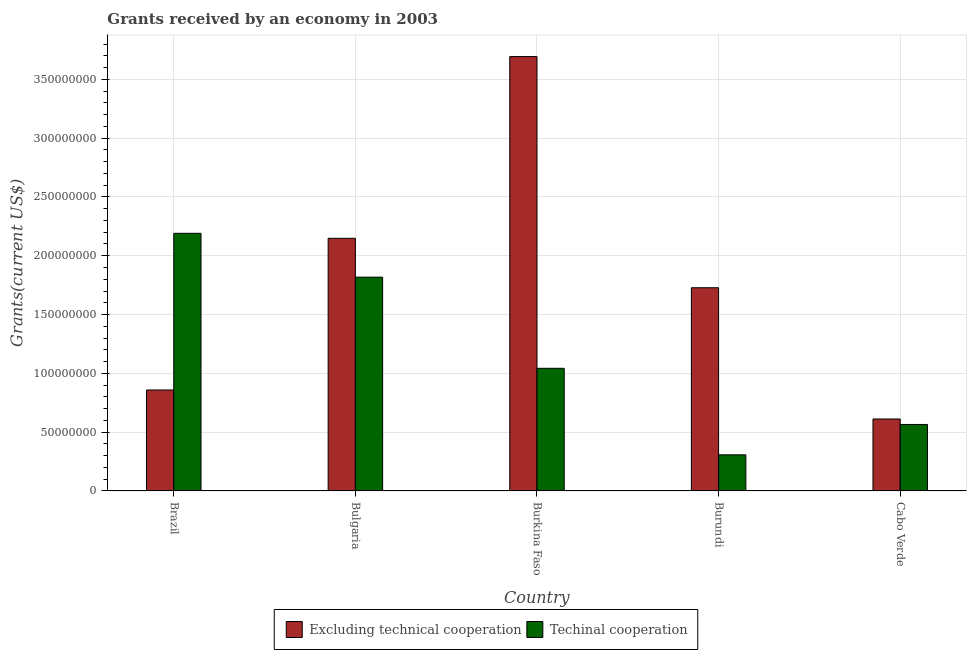How many groups of bars are there?
Your answer should be very brief. 5. What is the label of the 4th group of bars from the left?
Provide a succinct answer. Burundi. What is the amount of grants received(excluding technical cooperation) in Burundi?
Your answer should be compact. 1.73e+08. Across all countries, what is the maximum amount of grants received(including technical cooperation)?
Your answer should be very brief. 2.19e+08. Across all countries, what is the minimum amount of grants received(including technical cooperation)?
Offer a terse response. 3.07e+07. In which country was the amount of grants received(excluding technical cooperation) maximum?
Ensure brevity in your answer.  Burkina Faso. In which country was the amount of grants received(including technical cooperation) minimum?
Provide a short and direct response. Burundi. What is the total amount of grants received(excluding technical cooperation) in the graph?
Make the answer very short. 9.04e+08. What is the difference between the amount of grants received(excluding technical cooperation) in Burundi and that in Cabo Verde?
Keep it short and to the point. 1.12e+08. What is the difference between the amount of grants received(including technical cooperation) in Burundi and the amount of grants received(excluding technical cooperation) in Cabo Verde?
Make the answer very short. -3.05e+07. What is the average amount of grants received(excluding technical cooperation) per country?
Ensure brevity in your answer.  1.81e+08. What is the difference between the amount of grants received(including technical cooperation) and amount of grants received(excluding technical cooperation) in Burundi?
Provide a succinct answer. -1.42e+08. What is the ratio of the amount of grants received(including technical cooperation) in Brazil to that in Burundi?
Keep it short and to the point. 7.14. Is the amount of grants received(excluding technical cooperation) in Burundi less than that in Cabo Verde?
Offer a terse response. No. What is the difference between the highest and the second highest amount of grants received(excluding technical cooperation)?
Give a very brief answer. 1.55e+08. What is the difference between the highest and the lowest amount of grants received(including technical cooperation)?
Provide a succinct answer. 1.88e+08. In how many countries, is the amount of grants received(including technical cooperation) greater than the average amount of grants received(including technical cooperation) taken over all countries?
Give a very brief answer. 2. What does the 1st bar from the left in Cabo Verde represents?
Provide a succinct answer. Excluding technical cooperation. What does the 1st bar from the right in Bulgaria represents?
Your answer should be compact. Techinal cooperation. How many bars are there?
Keep it short and to the point. 10. Are all the bars in the graph horizontal?
Your answer should be very brief. No. How many countries are there in the graph?
Give a very brief answer. 5. Does the graph contain grids?
Offer a terse response. Yes. Where does the legend appear in the graph?
Give a very brief answer. Bottom center. How many legend labels are there?
Offer a terse response. 2. What is the title of the graph?
Give a very brief answer. Grants received by an economy in 2003. Does "current US$" appear as one of the legend labels in the graph?
Ensure brevity in your answer.  No. What is the label or title of the X-axis?
Offer a terse response. Country. What is the label or title of the Y-axis?
Provide a short and direct response. Grants(current US$). What is the Grants(current US$) in Excluding technical cooperation in Brazil?
Ensure brevity in your answer.  8.58e+07. What is the Grants(current US$) in Techinal cooperation in Brazil?
Give a very brief answer. 2.19e+08. What is the Grants(current US$) in Excluding technical cooperation in Bulgaria?
Give a very brief answer. 2.15e+08. What is the Grants(current US$) in Techinal cooperation in Bulgaria?
Your answer should be compact. 1.82e+08. What is the Grants(current US$) in Excluding technical cooperation in Burkina Faso?
Keep it short and to the point. 3.69e+08. What is the Grants(current US$) in Techinal cooperation in Burkina Faso?
Offer a terse response. 1.04e+08. What is the Grants(current US$) of Excluding technical cooperation in Burundi?
Your response must be concise. 1.73e+08. What is the Grants(current US$) in Techinal cooperation in Burundi?
Keep it short and to the point. 3.07e+07. What is the Grants(current US$) in Excluding technical cooperation in Cabo Verde?
Keep it short and to the point. 6.12e+07. What is the Grants(current US$) in Techinal cooperation in Cabo Verde?
Ensure brevity in your answer.  5.65e+07. Across all countries, what is the maximum Grants(current US$) of Excluding technical cooperation?
Provide a succinct answer. 3.69e+08. Across all countries, what is the maximum Grants(current US$) of Techinal cooperation?
Your answer should be compact. 2.19e+08. Across all countries, what is the minimum Grants(current US$) in Excluding technical cooperation?
Provide a short and direct response. 6.12e+07. Across all countries, what is the minimum Grants(current US$) in Techinal cooperation?
Make the answer very short. 3.07e+07. What is the total Grants(current US$) of Excluding technical cooperation in the graph?
Provide a short and direct response. 9.04e+08. What is the total Grants(current US$) of Techinal cooperation in the graph?
Make the answer very short. 5.92e+08. What is the difference between the Grants(current US$) in Excluding technical cooperation in Brazil and that in Bulgaria?
Ensure brevity in your answer.  -1.29e+08. What is the difference between the Grants(current US$) of Techinal cooperation in Brazil and that in Bulgaria?
Provide a succinct answer. 3.73e+07. What is the difference between the Grants(current US$) of Excluding technical cooperation in Brazil and that in Burkina Faso?
Give a very brief answer. -2.83e+08. What is the difference between the Grants(current US$) in Techinal cooperation in Brazil and that in Burkina Faso?
Provide a short and direct response. 1.15e+08. What is the difference between the Grants(current US$) of Excluding technical cooperation in Brazil and that in Burundi?
Give a very brief answer. -8.70e+07. What is the difference between the Grants(current US$) in Techinal cooperation in Brazil and that in Burundi?
Your answer should be very brief. 1.88e+08. What is the difference between the Grants(current US$) in Excluding technical cooperation in Brazil and that in Cabo Verde?
Provide a short and direct response. 2.47e+07. What is the difference between the Grants(current US$) of Techinal cooperation in Brazil and that in Cabo Verde?
Give a very brief answer. 1.63e+08. What is the difference between the Grants(current US$) in Excluding technical cooperation in Bulgaria and that in Burkina Faso?
Offer a terse response. -1.55e+08. What is the difference between the Grants(current US$) in Techinal cooperation in Bulgaria and that in Burkina Faso?
Offer a terse response. 7.75e+07. What is the difference between the Grants(current US$) of Excluding technical cooperation in Bulgaria and that in Burundi?
Offer a very short reply. 4.20e+07. What is the difference between the Grants(current US$) of Techinal cooperation in Bulgaria and that in Burundi?
Ensure brevity in your answer.  1.51e+08. What is the difference between the Grants(current US$) in Excluding technical cooperation in Bulgaria and that in Cabo Verde?
Your response must be concise. 1.54e+08. What is the difference between the Grants(current US$) of Techinal cooperation in Bulgaria and that in Cabo Verde?
Your answer should be compact. 1.25e+08. What is the difference between the Grants(current US$) in Excluding technical cooperation in Burkina Faso and that in Burundi?
Your response must be concise. 1.97e+08. What is the difference between the Grants(current US$) in Techinal cooperation in Burkina Faso and that in Burundi?
Your answer should be compact. 7.36e+07. What is the difference between the Grants(current US$) in Excluding technical cooperation in Burkina Faso and that in Cabo Verde?
Offer a very short reply. 3.08e+08. What is the difference between the Grants(current US$) in Techinal cooperation in Burkina Faso and that in Cabo Verde?
Keep it short and to the point. 4.78e+07. What is the difference between the Grants(current US$) of Excluding technical cooperation in Burundi and that in Cabo Verde?
Provide a short and direct response. 1.12e+08. What is the difference between the Grants(current US$) in Techinal cooperation in Burundi and that in Cabo Verde?
Offer a very short reply. -2.58e+07. What is the difference between the Grants(current US$) of Excluding technical cooperation in Brazil and the Grants(current US$) of Techinal cooperation in Bulgaria?
Offer a very short reply. -9.59e+07. What is the difference between the Grants(current US$) in Excluding technical cooperation in Brazil and the Grants(current US$) in Techinal cooperation in Burkina Faso?
Keep it short and to the point. -1.84e+07. What is the difference between the Grants(current US$) in Excluding technical cooperation in Brazil and the Grants(current US$) in Techinal cooperation in Burundi?
Give a very brief answer. 5.51e+07. What is the difference between the Grants(current US$) of Excluding technical cooperation in Brazil and the Grants(current US$) of Techinal cooperation in Cabo Verde?
Offer a very short reply. 2.93e+07. What is the difference between the Grants(current US$) in Excluding technical cooperation in Bulgaria and the Grants(current US$) in Techinal cooperation in Burkina Faso?
Provide a short and direct response. 1.11e+08. What is the difference between the Grants(current US$) in Excluding technical cooperation in Bulgaria and the Grants(current US$) in Techinal cooperation in Burundi?
Your response must be concise. 1.84e+08. What is the difference between the Grants(current US$) in Excluding technical cooperation in Bulgaria and the Grants(current US$) in Techinal cooperation in Cabo Verde?
Offer a very short reply. 1.58e+08. What is the difference between the Grants(current US$) in Excluding technical cooperation in Burkina Faso and the Grants(current US$) in Techinal cooperation in Burundi?
Give a very brief answer. 3.39e+08. What is the difference between the Grants(current US$) in Excluding technical cooperation in Burkina Faso and the Grants(current US$) in Techinal cooperation in Cabo Verde?
Your answer should be very brief. 3.13e+08. What is the difference between the Grants(current US$) of Excluding technical cooperation in Burundi and the Grants(current US$) of Techinal cooperation in Cabo Verde?
Ensure brevity in your answer.  1.16e+08. What is the average Grants(current US$) of Excluding technical cooperation per country?
Your answer should be compact. 1.81e+08. What is the average Grants(current US$) of Techinal cooperation per country?
Provide a succinct answer. 1.18e+08. What is the difference between the Grants(current US$) in Excluding technical cooperation and Grants(current US$) in Techinal cooperation in Brazil?
Provide a succinct answer. -1.33e+08. What is the difference between the Grants(current US$) in Excluding technical cooperation and Grants(current US$) in Techinal cooperation in Bulgaria?
Ensure brevity in your answer.  3.30e+07. What is the difference between the Grants(current US$) in Excluding technical cooperation and Grants(current US$) in Techinal cooperation in Burkina Faso?
Your response must be concise. 2.65e+08. What is the difference between the Grants(current US$) of Excluding technical cooperation and Grants(current US$) of Techinal cooperation in Burundi?
Your answer should be very brief. 1.42e+08. What is the difference between the Grants(current US$) in Excluding technical cooperation and Grants(current US$) in Techinal cooperation in Cabo Verde?
Provide a succinct answer. 4.64e+06. What is the ratio of the Grants(current US$) of Excluding technical cooperation in Brazil to that in Bulgaria?
Ensure brevity in your answer.  0.4. What is the ratio of the Grants(current US$) of Techinal cooperation in Brazil to that in Bulgaria?
Offer a terse response. 1.21. What is the ratio of the Grants(current US$) of Excluding technical cooperation in Brazil to that in Burkina Faso?
Ensure brevity in your answer.  0.23. What is the ratio of the Grants(current US$) of Techinal cooperation in Brazil to that in Burkina Faso?
Your response must be concise. 2.1. What is the ratio of the Grants(current US$) in Excluding technical cooperation in Brazil to that in Burundi?
Offer a very short reply. 0.5. What is the ratio of the Grants(current US$) in Techinal cooperation in Brazil to that in Burundi?
Your response must be concise. 7.14. What is the ratio of the Grants(current US$) in Excluding technical cooperation in Brazil to that in Cabo Verde?
Your answer should be compact. 1.4. What is the ratio of the Grants(current US$) in Techinal cooperation in Brazil to that in Cabo Verde?
Your answer should be very brief. 3.88. What is the ratio of the Grants(current US$) in Excluding technical cooperation in Bulgaria to that in Burkina Faso?
Your response must be concise. 0.58. What is the ratio of the Grants(current US$) in Techinal cooperation in Bulgaria to that in Burkina Faso?
Give a very brief answer. 1.74. What is the ratio of the Grants(current US$) in Excluding technical cooperation in Bulgaria to that in Burundi?
Provide a succinct answer. 1.24. What is the ratio of the Grants(current US$) of Techinal cooperation in Bulgaria to that in Burundi?
Ensure brevity in your answer.  5.92. What is the ratio of the Grants(current US$) of Excluding technical cooperation in Bulgaria to that in Cabo Verde?
Your response must be concise. 3.51. What is the ratio of the Grants(current US$) in Techinal cooperation in Bulgaria to that in Cabo Verde?
Provide a short and direct response. 3.22. What is the ratio of the Grants(current US$) in Excluding technical cooperation in Burkina Faso to that in Burundi?
Provide a succinct answer. 2.14. What is the ratio of the Grants(current US$) of Techinal cooperation in Burkina Faso to that in Burundi?
Offer a very short reply. 3.4. What is the ratio of the Grants(current US$) of Excluding technical cooperation in Burkina Faso to that in Cabo Verde?
Provide a short and direct response. 6.04. What is the ratio of the Grants(current US$) of Techinal cooperation in Burkina Faso to that in Cabo Verde?
Provide a short and direct response. 1.84. What is the ratio of the Grants(current US$) of Excluding technical cooperation in Burundi to that in Cabo Verde?
Offer a very short reply. 2.82. What is the ratio of the Grants(current US$) of Techinal cooperation in Burundi to that in Cabo Verde?
Your answer should be very brief. 0.54. What is the difference between the highest and the second highest Grants(current US$) in Excluding technical cooperation?
Offer a very short reply. 1.55e+08. What is the difference between the highest and the second highest Grants(current US$) of Techinal cooperation?
Offer a very short reply. 3.73e+07. What is the difference between the highest and the lowest Grants(current US$) of Excluding technical cooperation?
Offer a very short reply. 3.08e+08. What is the difference between the highest and the lowest Grants(current US$) in Techinal cooperation?
Your response must be concise. 1.88e+08. 